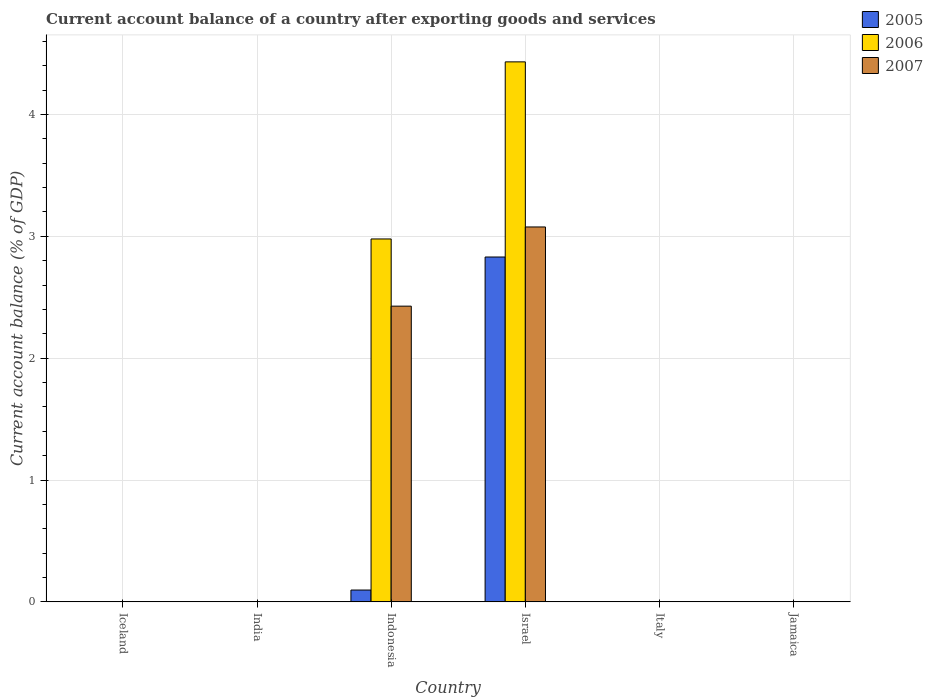How many different coloured bars are there?
Offer a very short reply. 3. Are the number of bars per tick equal to the number of legend labels?
Offer a very short reply. No. How many bars are there on the 2nd tick from the left?
Provide a succinct answer. 0. What is the label of the 3rd group of bars from the left?
Offer a terse response. Indonesia. Across all countries, what is the maximum account balance in 2005?
Give a very brief answer. 2.83. Across all countries, what is the minimum account balance in 2005?
Make the answer very short. 0. In which country was the account balance in 2006 maximum?
Your answer should be compact. Israel. What is the total account balance in 2005 in the graph?
Your answer should be compact. 2.93. What is the difference between the account balance in 2005 in India and the account balance in 2006 in Israel?
Ensure brevity in your answer.  -4.43. What is the average account balance in 2006 per country?
Ensure brevity in your answer.  1.24. What is the difference between the account balance of/in 2006 and account balance of/in 2005 in Indonesia?
Ensure brevity in your answer.  2.88. Is the difference between the account balance in 2006 in Indonesia and Israel greater than the difference between the account balance in 2005 in Indonesia and Israel?
Make the answer very short. Yes. What is the difference between the highest and the lowest account balance in 2005?
Your answer should be compact. 2.83. Are all the bars in the graph horizontal?
Make the answer very short. No. How many countries are there in the graph?
Provide a short and direct response. 6. What is the difference between two consecutive major ticks on the Y-axis?
Your answer should be compact. 1. Does the graph contain any zero values?
Provide a short and direct response. Yes. Where does the legend appear in the graph?
Provide a succinct answer. Top right. How many legend labels are there?
Your response must be concise. 3. What is the title of the graph?
Ensure brevity in your answer.  Current account balance of a country after exporting goods and services. Does "2010" appear as one of the legend labels in the graph?
Your answer should be compact. No. What is the label or title of the X-axis?
Provide a short and direct response. Country. What is the label or title of the Y-axis?
Your answer should be very brief. Current account balance (% of GDP). What is the Current account balance (% of GDP) in 2006 in Iceland?
Provide a succinct answer. 0. What is the Current account balance (% of GDP) of 2007 in Iceland?
Ensure brevity in your answer.  0. What is the Current account balance (% of GDP) of 2006 in India?
Your answer should be compact. 0. What is the Current account balance (% of GDP) of 2005 in Indonesia?
Give a very brief answer. 0.1. What is the Current account balance (% of GDP) in 2006 in Indonesia?
Keep it short and to the point. 2.98. What is the Current account balance (% of GDP) of 2007 in Indonesia?
Your answer should be compact. 2.43. What is the Current account balance (% of GDP) of 2005 in Israel?
Provide a short and direct response. 2.83. What is the Current account balance (% of GDP) in 2006 in Israel?
Give a very brief answer. 4.43. What is the Current account balance (% of GDP) in 2007 in Israel?
Offer a terse response. 3.08. What is the Current account balance (% of GDP) in 2007 in Italy?
Provide a short and direct response. 0. What is the Current account balance (% of GDP) in 2006 in Jamaica?
Your answer should be very brief. 0. Across all countries, what is the maximum Current account balance (% of GDP) of 2005?
Offer a very short reply. 2.83. Across all countries, what is the maximum Current account balance (% of GDP) of 2006?
Your response must be concise. 4.43. Across all countries, what is the maximum Current account balance (% of GDP) in 2007?
Provide a short and direct response. 3.08. Across all countries, what is the minimum Current account balance (% of GDP) in 2005?
Your answer should be very brief. 0. Across all countries, what is the minimum Current account balance (% of GDP) in 2006?
Offer a terse response. 0. What is the total Current account balance (% of GDP) in 2005 in the graph?
Ensure brevity in your answer.  2.93. What is the total Current account balance (% of GDP) in 2006 in the graph?
Give a very brief answer. 7.41. What is the total Current account balance (% of GDP) in 2007 in the graph?
Your answer should be compact. 5.5. What is the difference between the Current account balance (% of GDP) in 2005 in Indonesia and that in Israel?
Your response must be concise. -2.73. What is the difference between the Current account balance (% of GDP) in 2006 in Indonesia and that in Israel?
Your response must be concise. -1.45. What is the difference between the Current account balance (% of GDP) in 2007 in Indonesia and that in Israel?
Your response must be concise. -0.65. What is the difference between the Current account balance (% of GDP) of 2005 in Indonesia and the Current account balance (% of GDP) of 2006 in Israel?
Give a very brief answer. -4.34. What is the difference between the Current account balance (% of GDP) in 2005 in Indonesia and the Current account balance (% of GDP) in 2007 in Israel?
Provide a succinct answer. -2.98. What is the difference between the Current account balance (% of GDP) of 2006 in Indonesia and the Current account balance (% of GDP) of 2007 in Israel?
Your answer should be very brief. -0.1. What is the average Current account balance (% of GDP) of 2005 per country?
Give a very brief answer. 0.49. What is the average Current account balance (% of GDP) in 2006 per country?
Your answer should be very brief. 1.24. What is the average Current account balance (% of GDP) in 2007 per country?
Ensure brevity in your answer.  0.92. What is the difference between the Current account balance (% of GDP) in 2005 and Current account balance (% of GDP) in 2006 in Indonesia?
Offer a terse response. -2.88. What is the difference between the Current account balance (% of GDP) of 2005 and Current account balance (% of GDP) of 2007 in Indonesia?
Your answer should be very brief. -2.33. What is the difference between the Current account balance (% of GDP) of 2006 and Current account balance (% of GDP) of 2007 in Indonesia?
Your answer should be compact. 0.55. What is the difference between the Current account balance (% of GDP) in 2005 and Current account balance (% of GDP) in 2006 in Israel?
Provide a succinct answer. -1.6. What is the difference between the Current account balance (% of GDP) of 2005 and Current account balance (% of GDP) of 2007 in Israel?
Your answer should be compact. -0.25. What is the difference between the Current account balance (% of GDP) of 2006 and Current account balance (% of GDP) of 2007 in Israel?
Give a very brief answer. 1.35. What is the ratio of the Current account balance (% of GDP) of 2005 in Indonesia to that in Israel?
Keep it short and to the point. 0.03. What is the ratio of the Current account balance (% of GDP) of 2006 in Indonesia to that in Israel?
Provide a short and direct response. 0.67. What is the ratio of the Current account balance (% of GDP) of 2007 in Indonesia to that in Israel?
Give a very brief answer. 0.79. What is the difference between the highest and the lowest Current account balance (% of GDP) of 2005?
Offer a very short reply. 2.83. What is the difference between the highest and the lowest Current account balance (% of GDP) in 2006?
Your answer should be compact. 4.43. What is the difference between the highest and the lowest Current account balance (% of GDP) of 2007?
Offer a terse response. 3.08. 